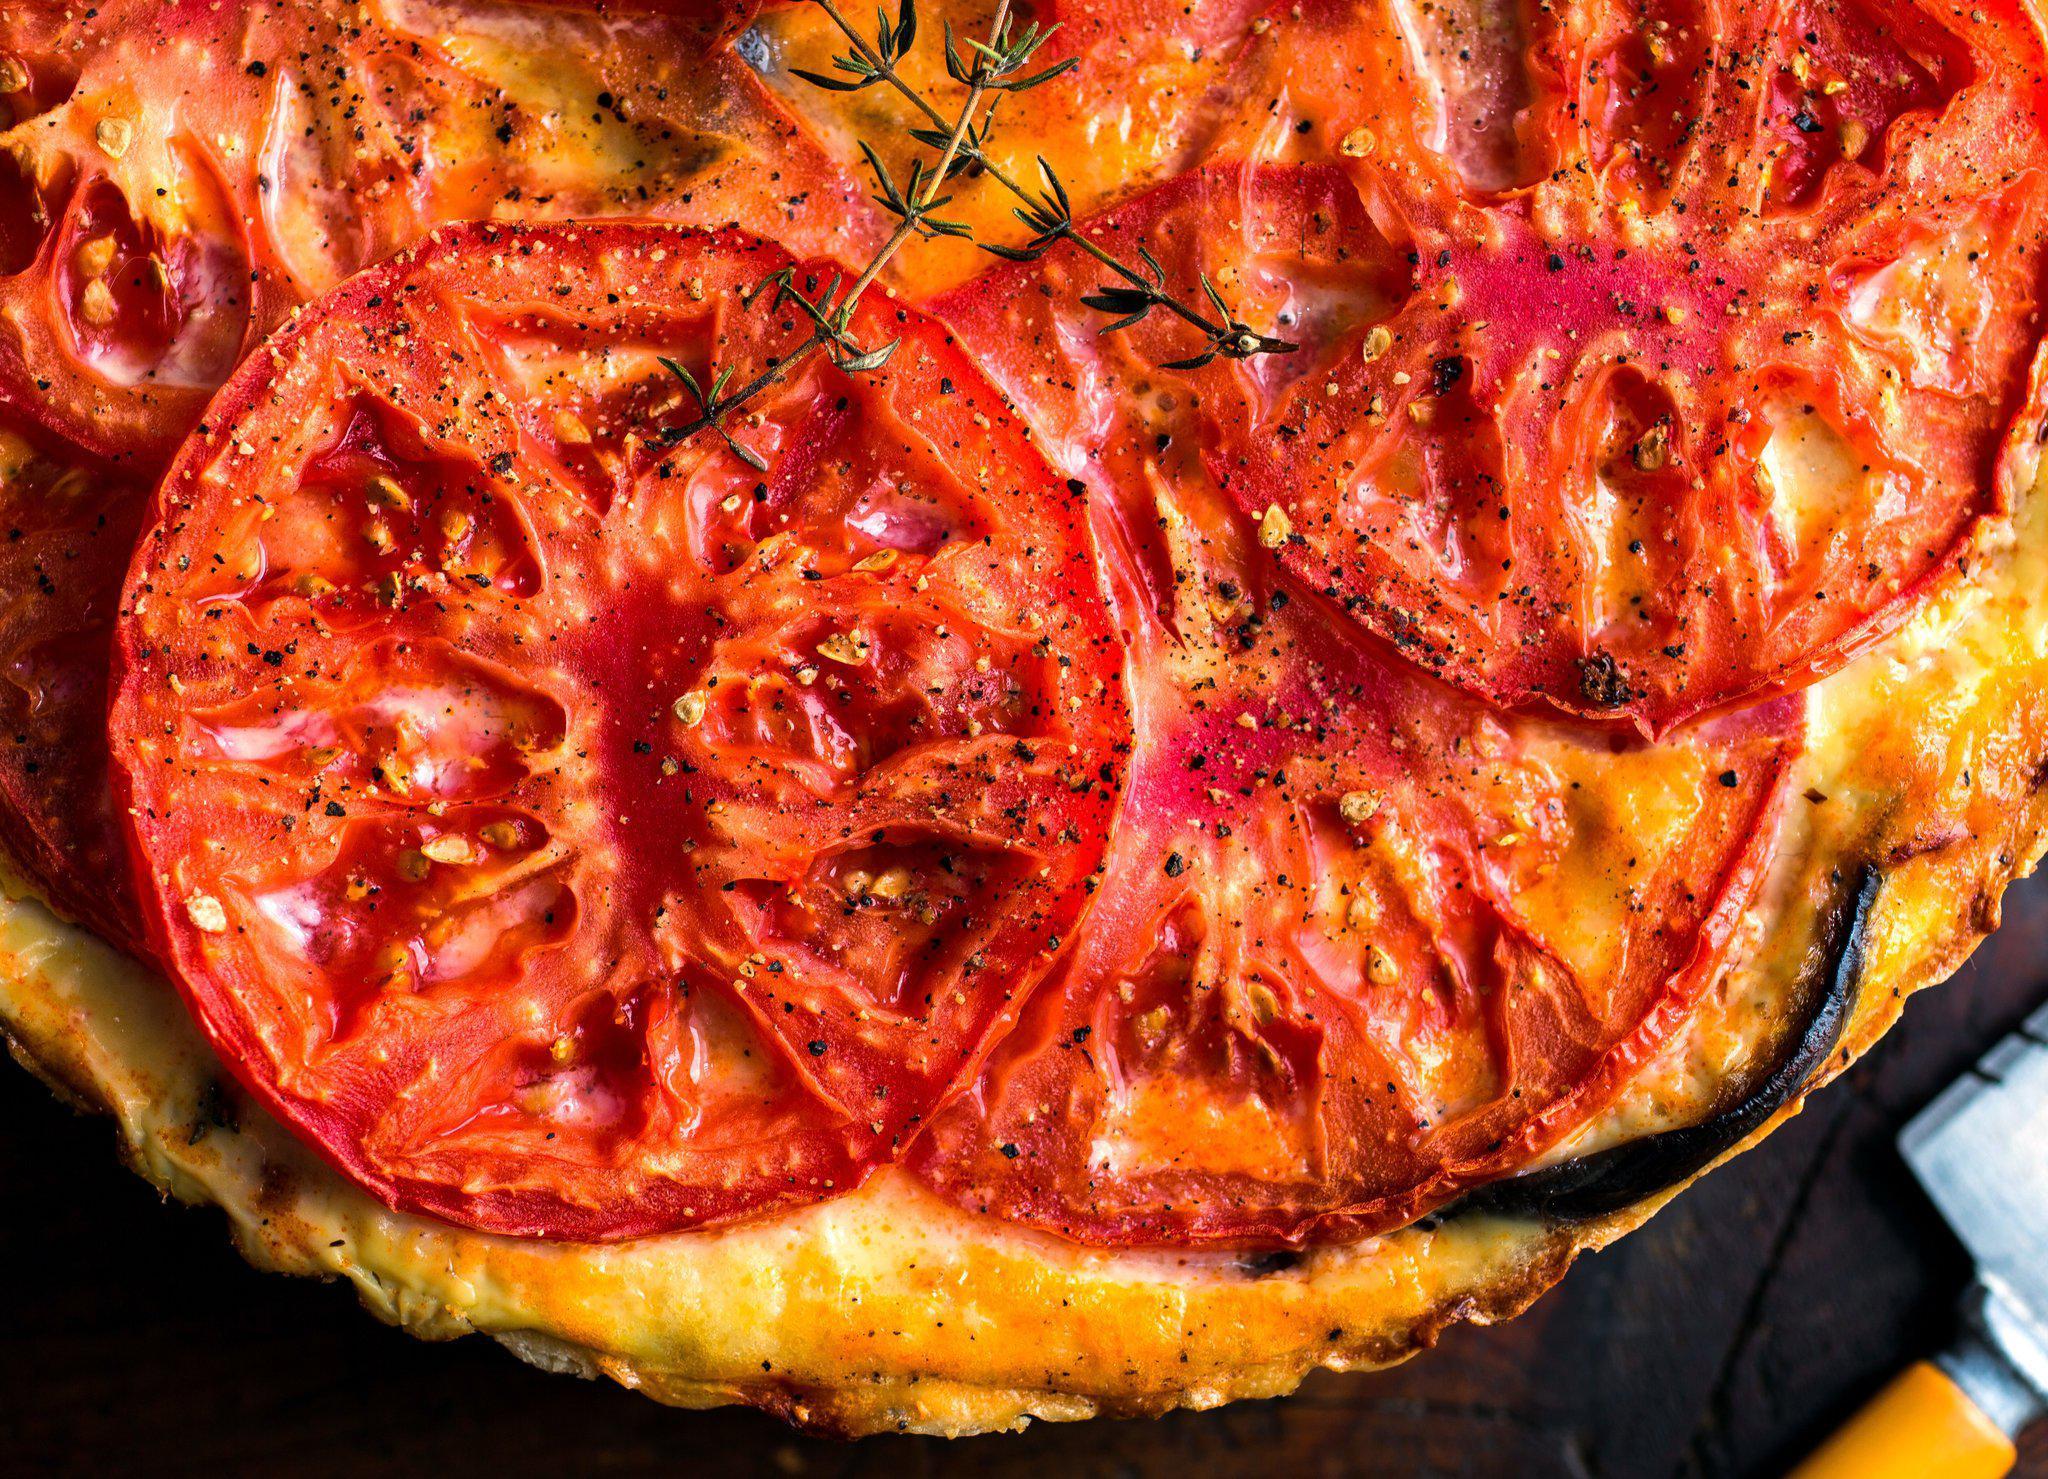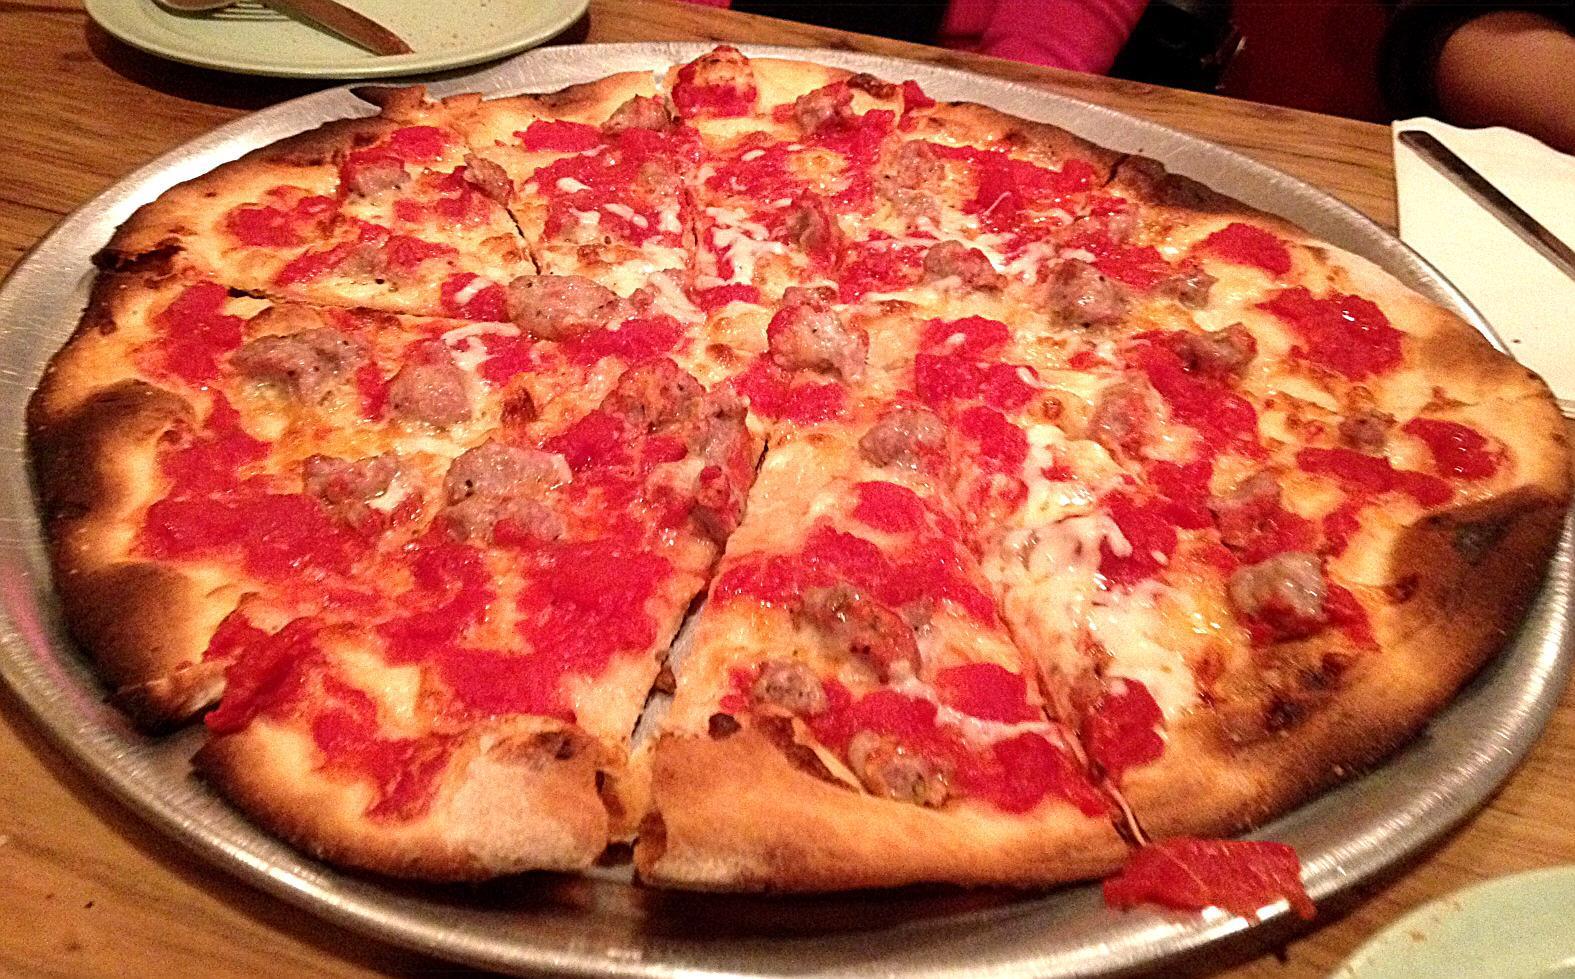The first image is the image on the left, the second image is the image on the right. Evaluate the accuracy of this statement regarding the images: "Each image shows a pizza with no slices removed, and one image features a pizza topped with round tomato slices and a green leafy garnish.". Is it true? Answer yes or no. Yes. The first image is the image on the left, the second image is the image on the right. Given the left and right images, does the statement "Large slices of tomato sit on top of a pizza." hold true? Answer yes or no. Yes. 